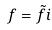Convert formula to latex. <formula><loc_0><loc_0><loc_500><loc_500>f = \tilde { f } i</formula> 